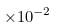<formula> <loc_0><loc_0><loc_500><loc_500>\times 1 0 ^ { - 2 }</formula> 